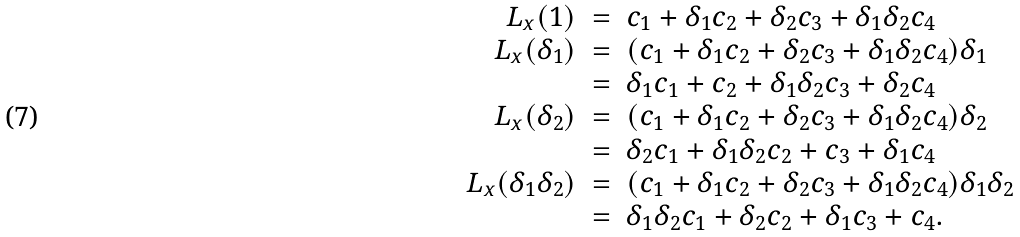Convert formula to latex. <formula><loc_0><loc_0><loc_500><loc_500>\begin{array} { r c l } L _ { x } ( 1 ) & = & c _ { 1 } + \delta _ { 1 } c _ { 2 } + \delta _ { 2 } c _ { 3 } + \delta _ { 1 } \delta _ { 2 } c _ { 4 } \\ L _ { x } ( \delta _ { 1 } ) & = & ( c _ { 1 } + \delta _ { 1 } c _ { 2 } + \delta _ { 2 } c _ { 3 } + \delta _ { 1 } \delta _ { 2 } c _ { 4 } ) \delta _ { 1 } \\ & = & \delta _ { 1 } c _ { 1 } + c _ { 2 } + \delta _ { 1 } \delta _ { 2 } c _ { 3 } + \delta _ { 2 } c _ { 4 } \\ L _ { x } ( \delta _ { 2 } ) & = & ( c _ { 1 } + \delta _ { 1 } c _ { 2 } + \delta _ { 2 } c _ { 3 } + \delta _ { 1 } \delta _ { 2 } c _ { 4 } ) \delta _ { 2 } \\ & = & \delta _ { 2 } c _ { 1 } + \delta _ { 1 } \delta _ { 2 } c _ { 2 } + c _ { 3 } + \delta _ { 1 } c _ { 4 } \\ L _ { x } ( \delta _ { 1 } \delta _ { 2 } ) & = & ( c _ { 1 } + \delta _ { 1 } c _ { 2 } + \delta _ { 2 } c _ { 3 } + \delta _ { 1 } \delta _ { 2 } c _ { 4 } ) \delta _ { 1 } \delta _ { 2 } \\ & = & \delta _ { 1 } \delta _ { 2 } c _ { 1 } + \delta _ { 2 } c _ { 2 } + \delta _ { 1 } c _ { 3 } + c _ { 4 } . \end{array}</formula> 